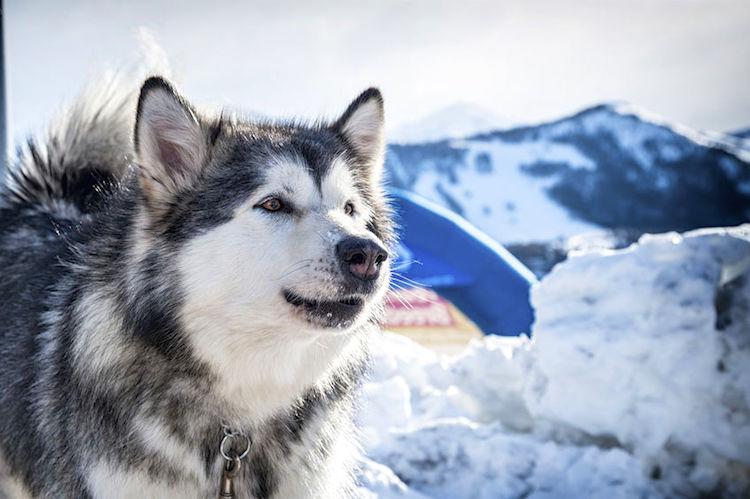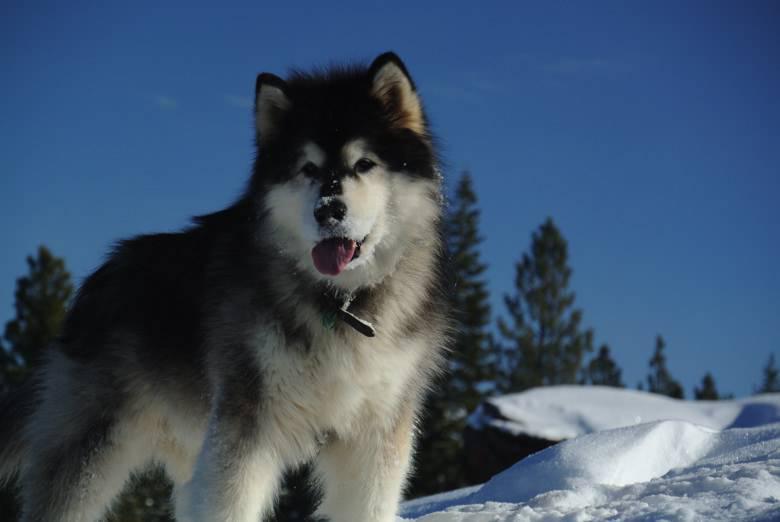The first image is the image on the left, the second image is the image on the right. Considering the images on both sides, is "There are exactly two dogs in the snow." valid? Answer yes or no. Yes. The first image is the image on the left, the second image is the image on the right. Analyze the images presented: Is the assertion "Each image contains one husky dog, but only one of the images features a dog with its tongue hanging out." valid? Answer yes or no. Yes. 